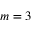<formula> <loc_0><loc_0><loc_500><loc_500>m = 3</formula> 